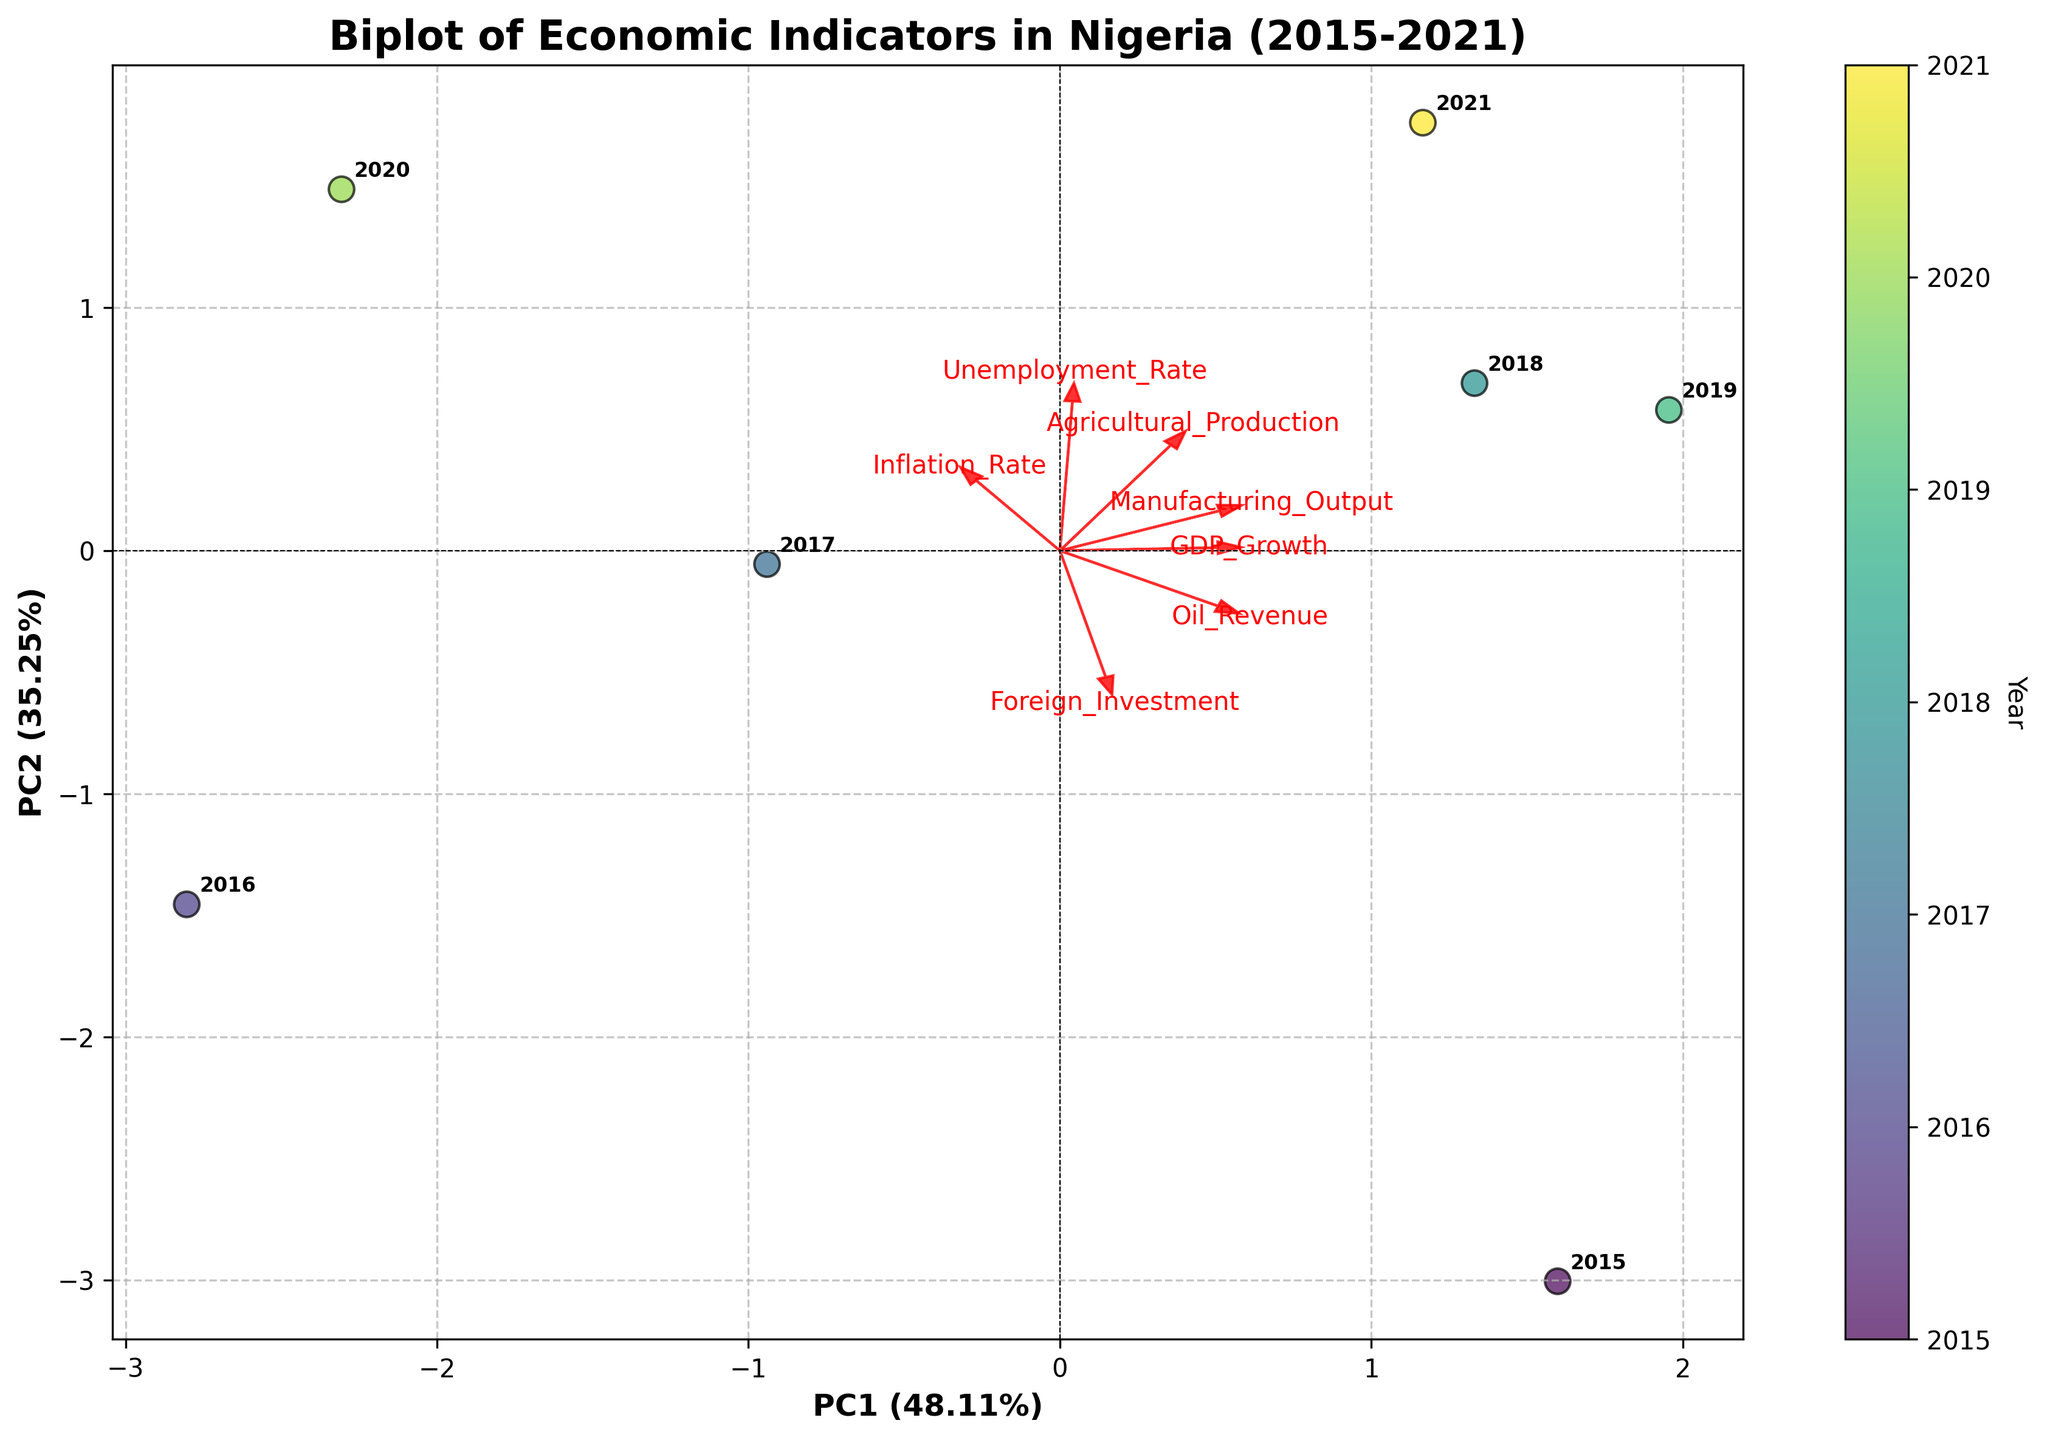What is the title of the biplot? The title is prominently displayed at the top of the figure and provides a quick summary of what the plot is about.
Answer: Biplot of Economic Indicators in Nigeria (2015-2021) How many years of data are represented in the biplot? Each data point represents a year, which can be counted by looking at the data points on the plot and their annotations.
Answer: 7 Which year has the highest GDP Growth? The color mapping on the scatter plot indicates different years. The points can be visually examined to find the one located closest to the positive side of the GDP Growth arrow.
Answer: 2021 What is the relationship between GDP Growth and Unemployment Rate based on the biplot? Observing the direction and alignment of the arrows for GDP Growth and Unemployment Rate can give insights. If they point in opposite directions, it indicates a negative relationship; if they point in the same direction, it indicates a positive relationship.
Answer: Negative Which economic indicator is most closely associated with PC1 (the first principal component)? By looking at the arrows and their alignment with the PC1 axis, the indicator with the arrow most aligned to the PC1 axis shows the highest association.
Answer: Foreign Investment How do Oil Revenue and Manufacturing Output compare in relation to PC2 (the second principal component)? By examining the angles at which the arrows for Oil Revenue and Manufacturing Output point relative to the PC2 axis, we can determine the comparative contributions to PC2.
Answer: Oil Revenue contributes more to PC2 Between which years did the GDP Growth decrease the most sharply? Identifying points on the plot that are close together temporally but far apart in terms of their positions in the direction of the GDP Growth arrow will highlight this.
Answer: 2015 to 2016 Which two economic indicators seem to have the strongest positive relationship? The arrows pointing in the same direction or having a very small angle between them indicate the strongest positive relationship.
Answer: Agricultural Production and Manufacturing Output What is the primary difference in economic indicators between 2015 and 2021? By comparing the placements and angles of the points and the corresponding years, we can assess which indicators differ most between these years, particularly noting the directions of the arrows.
Answer: GDP Growth and Unemployment Rate How does the plot indicate the variance explained by each principal component? The labels on the x and y axes include the percentage of variance explained by PC1 and PC2, respectively.
Answer: PC1: 42.9%, PC2: 26.6% 